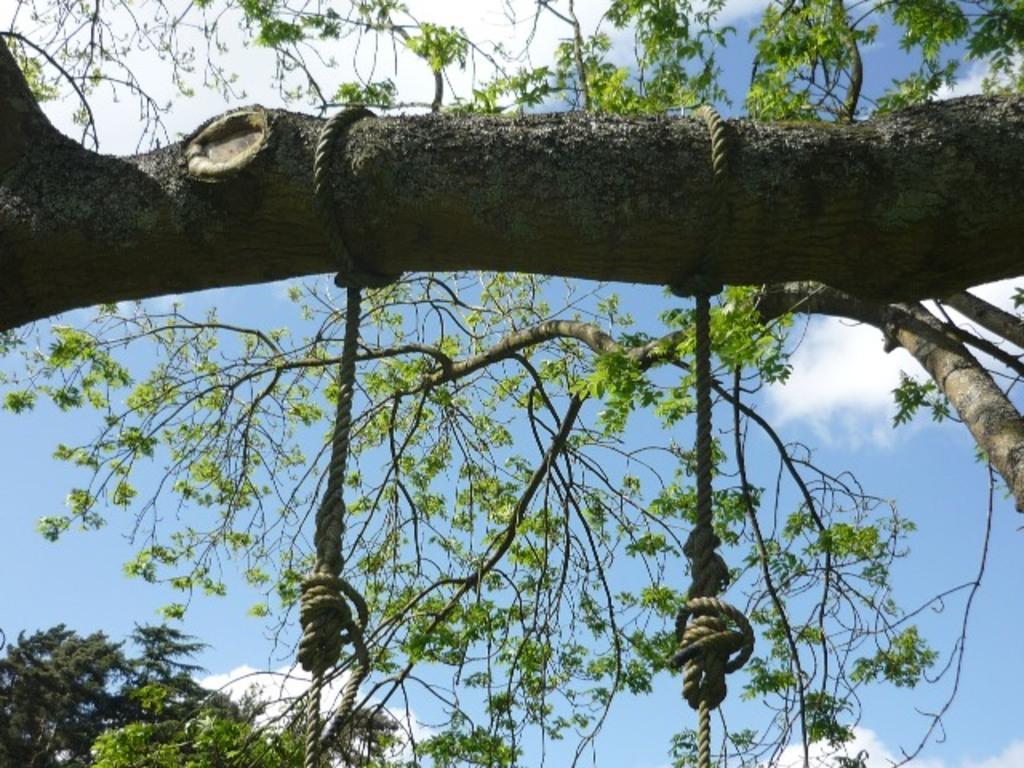In one or two sentences, can you explain what this image depicts? In this image there are two ropes on a branch of a tree, behind the branch there are leaves and branches. 